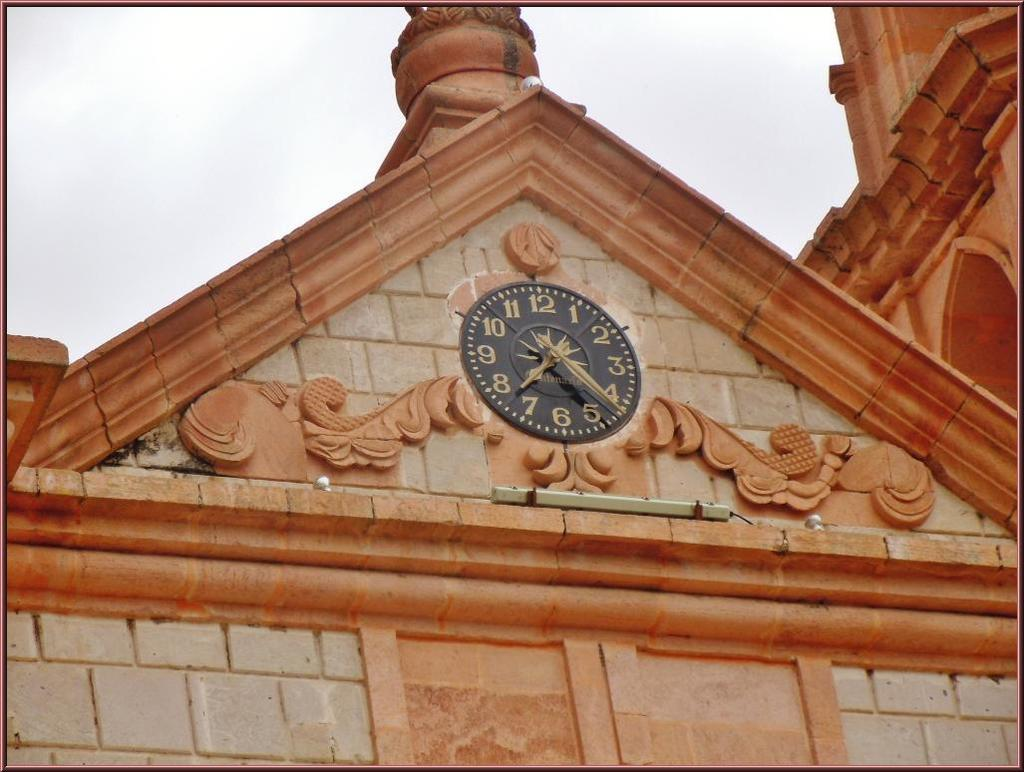<image>
Give a short and clear explanation of the subsequent image. A round clock on the pitch of a building that shows it to be 7:21. 